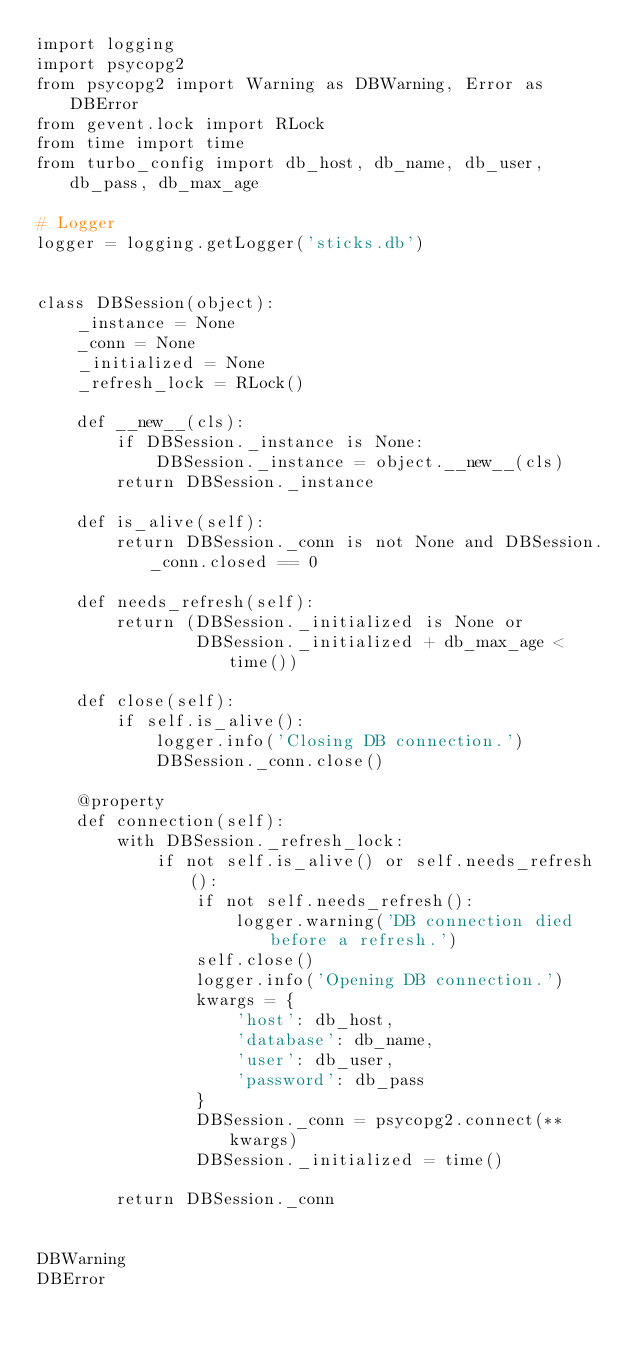Convert code to text. <code><loc_0><loc_0><loc_500><loc_500><_Python_>import logging
import psycopg2
from psycopg2 import Warning as DBWarning, Error as DBError
from gevent.lock import RLock
from time import time
from turbo_config import db_host, db_name, db_user, db_pass, db_max_age

# Logger
logger = logging.getLogger('sticks.db')


class DBSession(object):
    _instance = None
    _conn = None
    _initialized = None
    _refresh_lock = RLock()

    def __new__(cls):
        if DBSession._instance is None:
            DBSession._instance = object.__new__(cls)
        return DBSession._instance

    def is_alive(self):
        return DBSession._conn is not None and DBSession._conn.closed == 0

    def needs_refresh(self):
        return (DBSession._initialized is None or
                DBSession._initialized + db_max_age < time())

    def close(self):
        if self.is_alive():
            logger.info('Closing DB connection.')
            DBSession._conn.close()

    @property
    def connection(self):
        with DBSession._refresh_lock:
            if not self.is_alive() or self.needs_refresh():
                if not self.needs_refresh():
                    logger.warning('DB connection died before a refresh.')
                self.close()
                logger.info('Opening DB connection.')
                kwargs = {
                    'host': db_host,
                    'database': db_name,
                    'user': db_user,
                    'password': db_pass
                }
                DBSession._conn = psycopg2.connect(**kwargs)
                DBSession._initialized = time()

        return DBSession._conn


DBWarning
DBError
</code> 